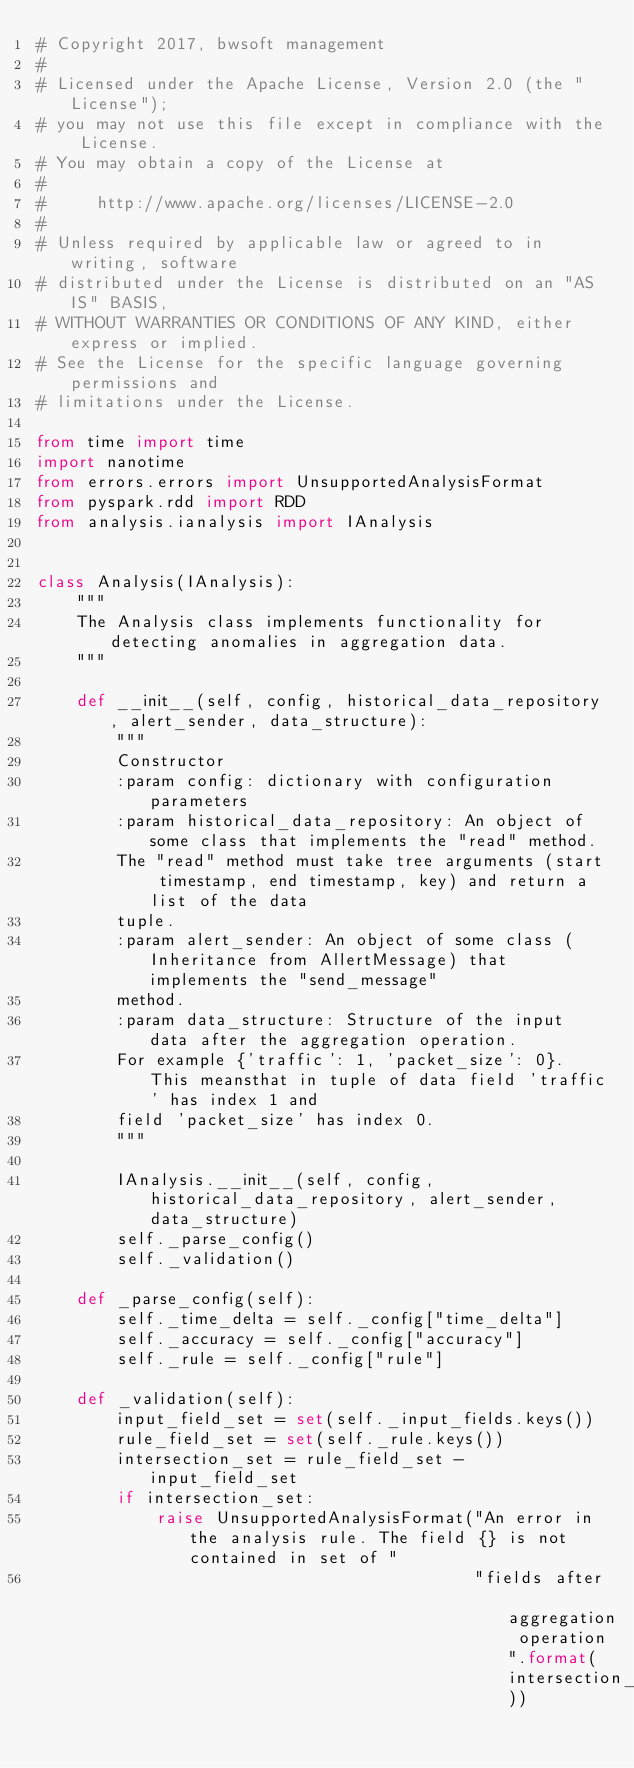<code> <loc_0><loc_0><loc_500><loc_500><_Python_># Copyright 2017, bwsoft management
#
# Licensed under the Apache License, Version 2.0 (the "License");
# you may not use this file except in compliance with the License.
# You may obtain a copy of the License at
#
#     http://www.apache.org/licenses/LICENSE-2.0
#
# Unless required by applicable law or agreed to in writing, software
# distributed under the License is distributed on an "AS IS" BASIS,
# WITHOUT WARRANTIES OR CONDITIONS OF ANY KIND, either express or implied.
# See the License for the specific language governing permissions and
# limitations under the License.

from time import time
import nanotime
from errors.errors import UnsupportedAnalysisFormat
from pyspark.rdd import RDD
from analysis.ianalysis import IAnalysis


class Analysis(IAnalysis):
    """
    The Analysis class implements functionality for detecting anomalies in aggregation data.
    """

    def __init__(self, config, historical_data_repository, alert_sender, data_structure):
        """
        Constructor
        :param config: dictionary with configuration parameters
        :param historical_data_repository: An object of some class that implements the "read" method. 
        The "read" method must take tree arguments (start timestamp, end timestamp, key) and return a list of the data 
        tuple.
        :param alert_sender: An object of some class (Inheritance from AllertMessage) that implements the "send_message" 
        method.
        :param data_structure: Structure of the input data after the aggregation operation. 
        For example {'traffic': 1, 'packet_size': 0}.  This meansthat in tuple of data field 'traffic' has index 1 and 
        field 'packet_size' has index 0.
        """

        IAnalysis.__init__(self, config, historical_data_repository, alert_sender, data_structure)
        self._parse_config()
        self._validation()

    def _parse_config(self):
        self._time_delta = self._config["time_delta"]
        self._accuracy = self._config["accuracy"]
        self._rule = self._config["rule"]

    def _validation(self):
        input_field_set = set(self._input_fields.keys())
        rule_field_set = set(self._rule.keys())
        intersection_set = rule_field_set - input_field_set
        if intersection_set:
            raise UnsupportedAnalysisFormat("An error in the analysis rule. The field {} is not contained in set of "
                                            "fields after aggregation operation".format(intersection_set))
</code> 